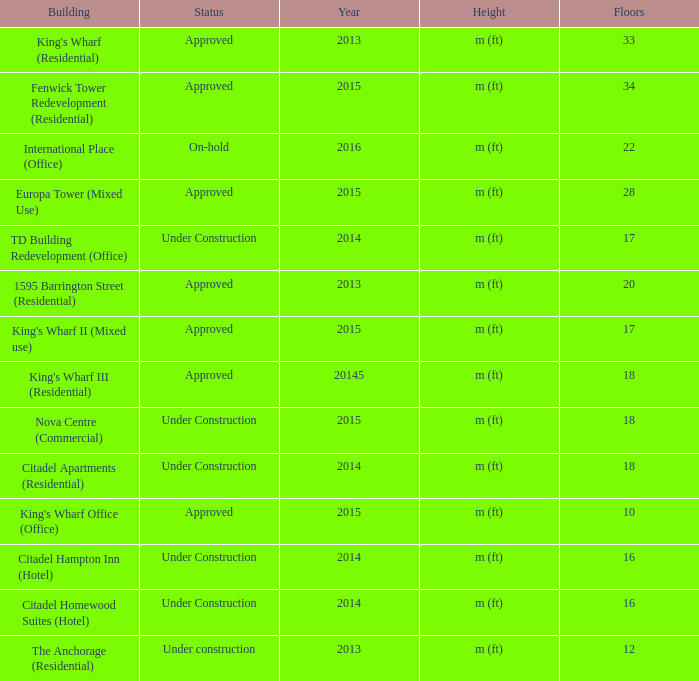What is the status of the building with less than 18 floors and later than 2013? Under Construction, Approved, Approved, Under Construction, Under Construction. 